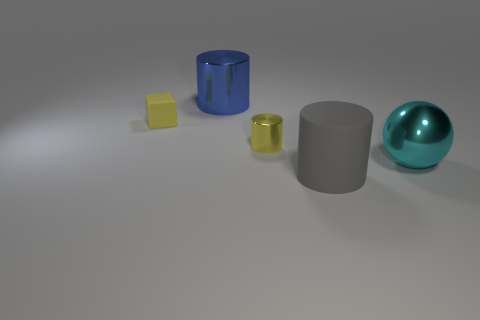Do the small thing that is to the left of the blue metallic object and the metal ball have the same color?
Give a very brief answer. No. There is a object that is in front of the large thing to the right of the big gray matte cylinder; how many large objects are on the right side of it?
Keep it short and to the point. 1. How many cylinders are behind the big cyan ball and right of the big blue shiny object?
Ensure brevity in your answer.  1. What is the shape of the tiny thing that is the same color as the small cylinder?
Make the answer very short. Cube. Does the cube have the same material as the gray thing?
Provide a short and direct response. Yes. There is a rubber thing that is in front of the big shiny object that is in front of the small yellow cylinder that is behind the large cyan ball; what shape is it?
Your answer should be very brief. Cylinder. Are there fewer tiny yellow metallic cylinders behind the yellow shiny cylinder than matte things in front of the yellow rubber thing?
Make the answer very short. Yes. What is the shape of the yellow thing on the right side of the matte thing behind the large cyan metallic object?
Your answer should be very brief. Cylinder. Is there any other thing that is the same color as the tiny cube?
Your response must be concise. Yes. Is the metallic ball the same color as the small block?
Ensure brevity in your answer.  No. 